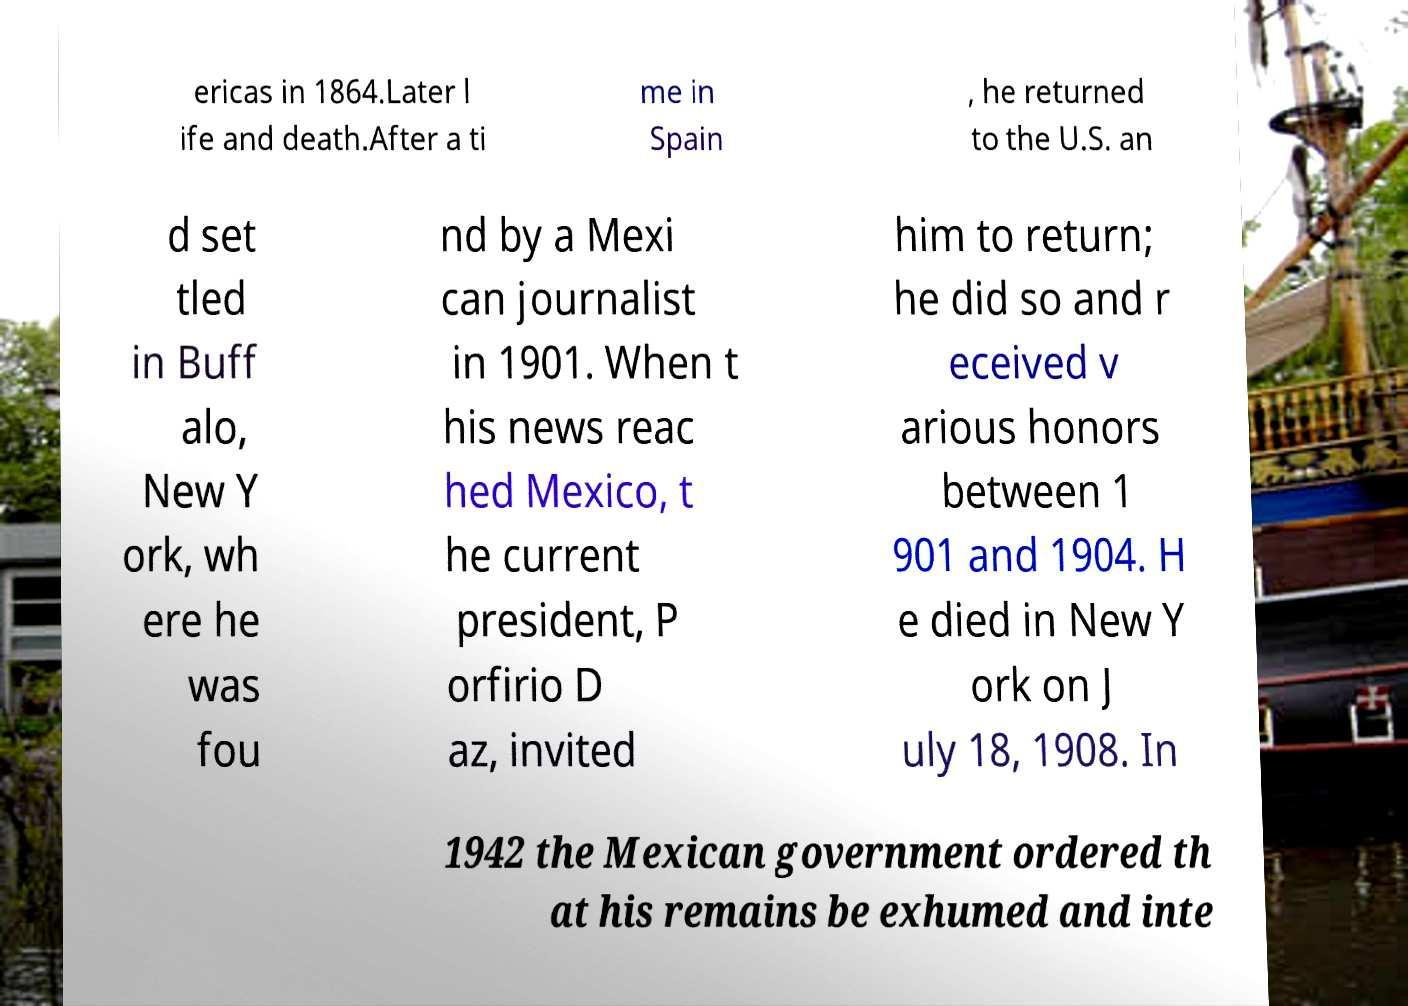Can you accurately transcribe the text from the provided image for me? ericas in 1864.Later l ife and death.After a ti me in Spain , he returned to the U.S. an d set tled in Buff alo, New Y ork, wh ere he was fou nd by a Mexi can journalist in 1901. When t his news reac hed Mexico, t he current president, P orfirio D az, invited him to return; he did so and r eceived v arious honors between 1 901 and 1904. H e died in New Y ork on J uly 18, 1908. In 1942 the Mexican government ordered th at his remains be exhumed and inte 